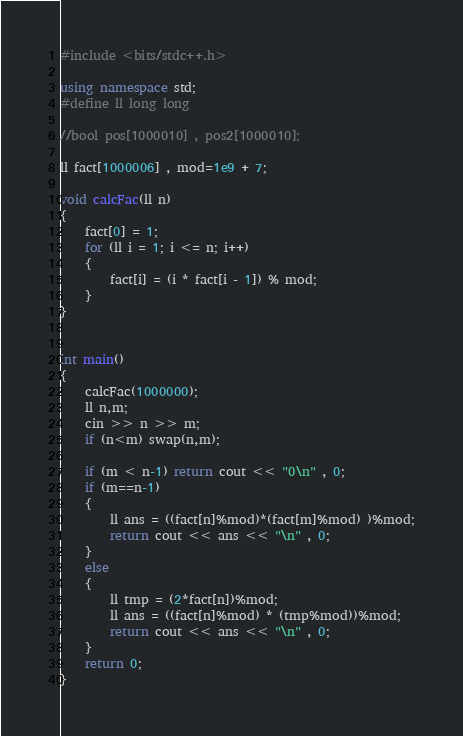<code> <loc_0><loc_0><loc_500><loc_500><_C++_>#include <bits/stdc++.h>

using namespace std;
#define ll long long

//bool pos[1000010] , pos2[1000010];

ll fact[1000006] , mod=1e9 + 7;

void calcFac(ll n)
{
    fact[0] = 1;
    for (ll i = 1; i <= n; i++)
    {
        fact[i] = (i * fact[i - 1]) % mod;
    }
}


int main()
{
    calcFac(1000000);
    ll n,m;
    cin >> n >> m;
    if (n<m) swap(n,m);

    if (m < n-1) return cout << "0\n" , 0;
    if (m==n-1)
    {
        ll ans = ((fact[n]%mod)*(fact[m]%mod) )%mod;
        return cout << ans << "\n" , 0;
    }
    else
    {
        ll tmp = (2*fact[n])%mod;
        ll ans = ((fact[n]%mod) * (tmp%mod))%mod;
        return cout << ans << "\n" , 0;
    }
    return 0;
}
</code> 